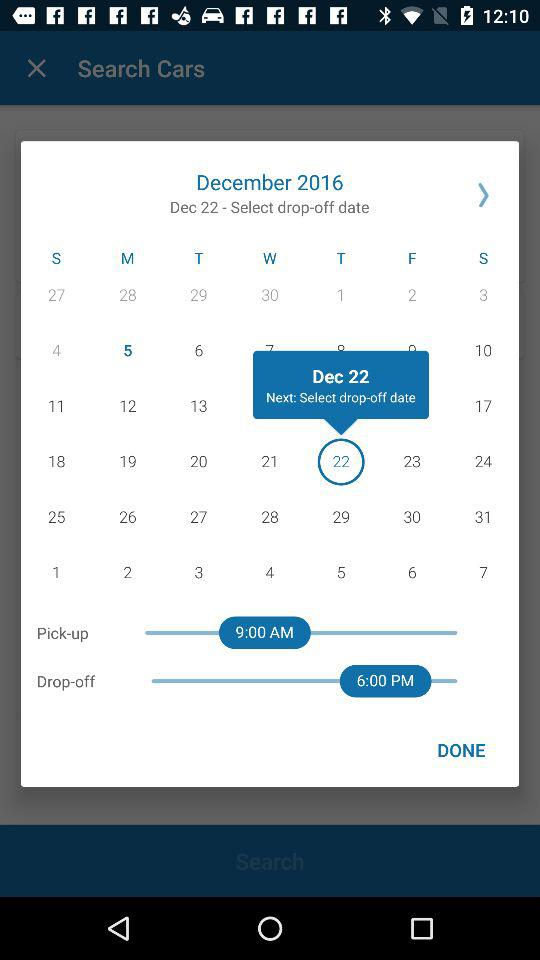When will it be dropped off? It will be dropped off at 6:00 pm. 